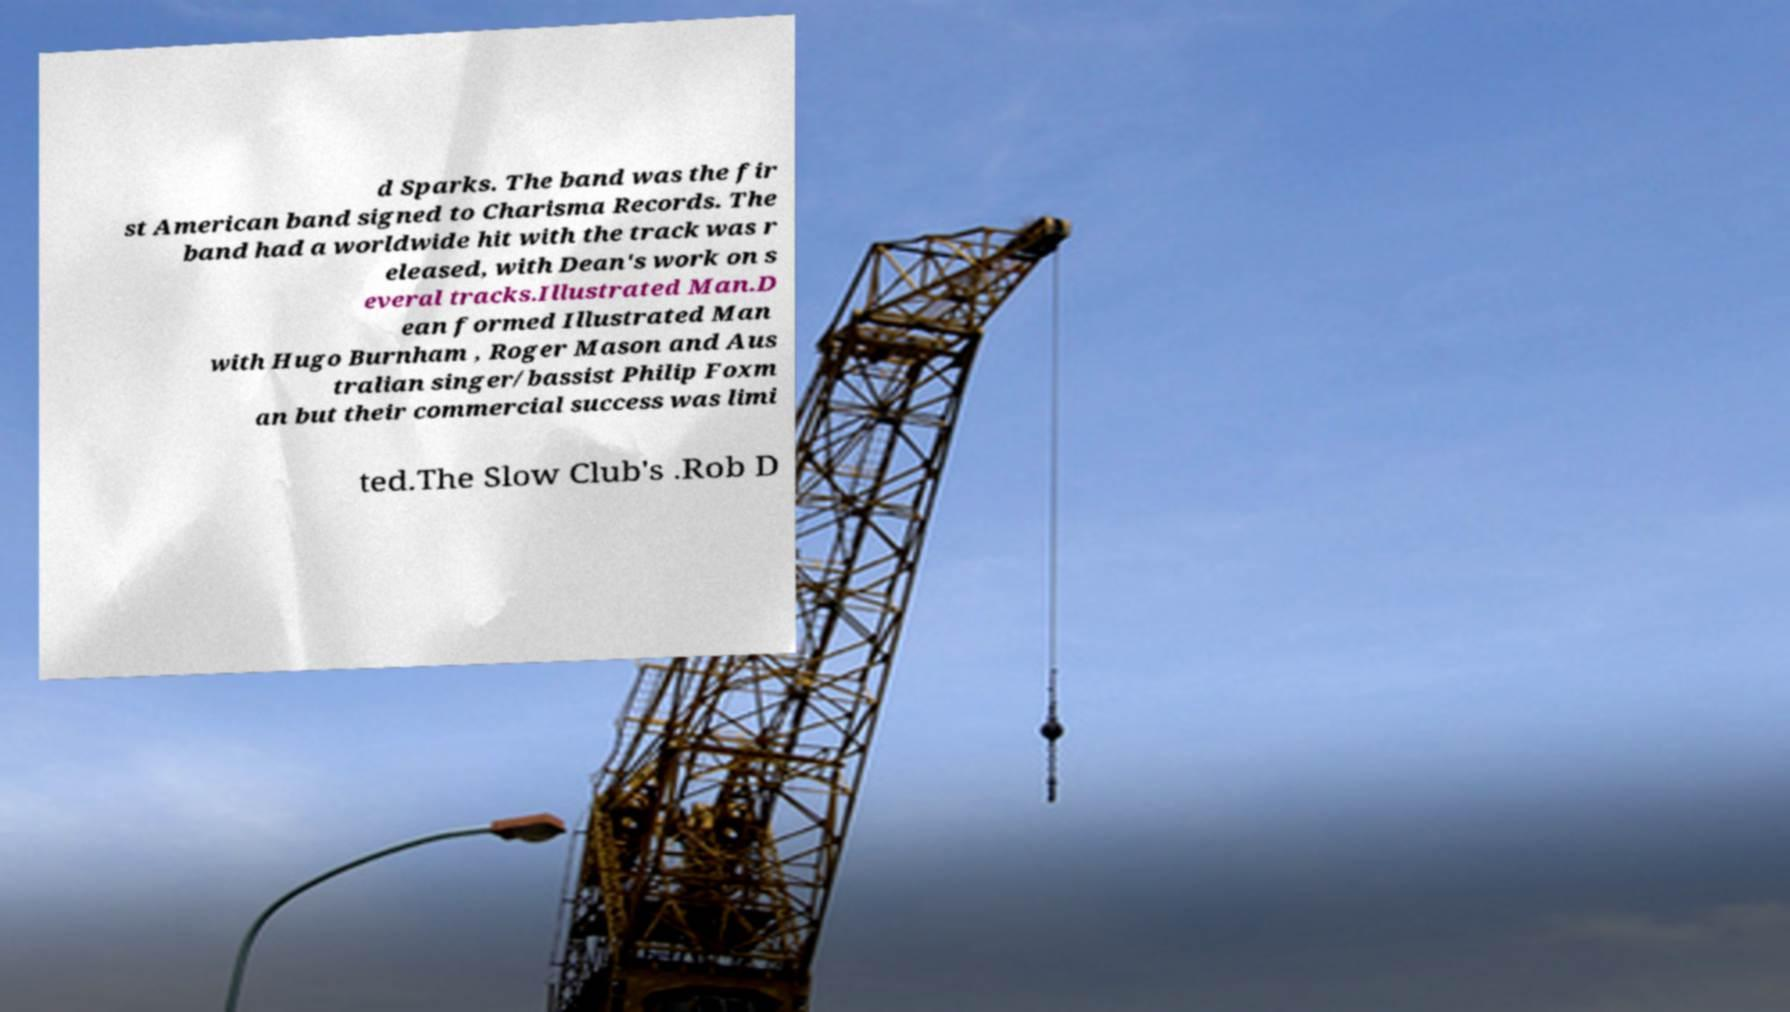For documentation purposes, I need the text within this image transcribed. Could you provide that? d Sparks. The band was the fir st American band signed to Charisma Records. The band had a worldwide hit with the track was r eleased, with Dean's work on s everal tracks.Illustrated Man.D ean formed Illustrated Man with Hugo Burnham , Roger Mason and Aus tralian singer/bassist Philip Foxm an but their commercial success was limi ted.The Slow Club's .Rob D 